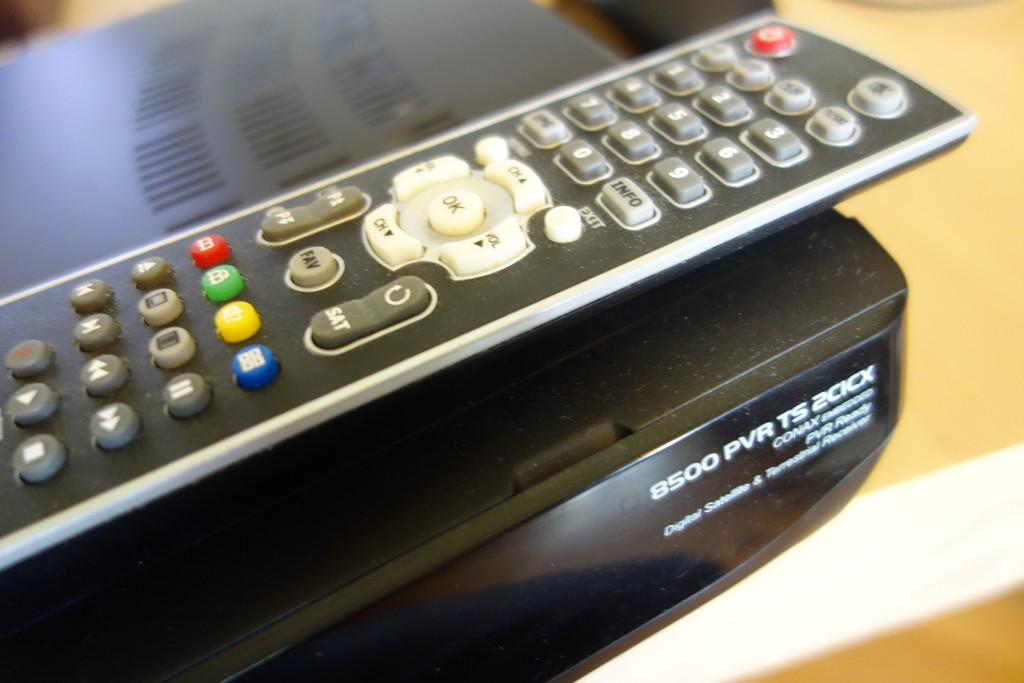<image>
Offer a succinct explanation of the picture presented. A close up of a remote control atop a Contax digital satellite receiver 